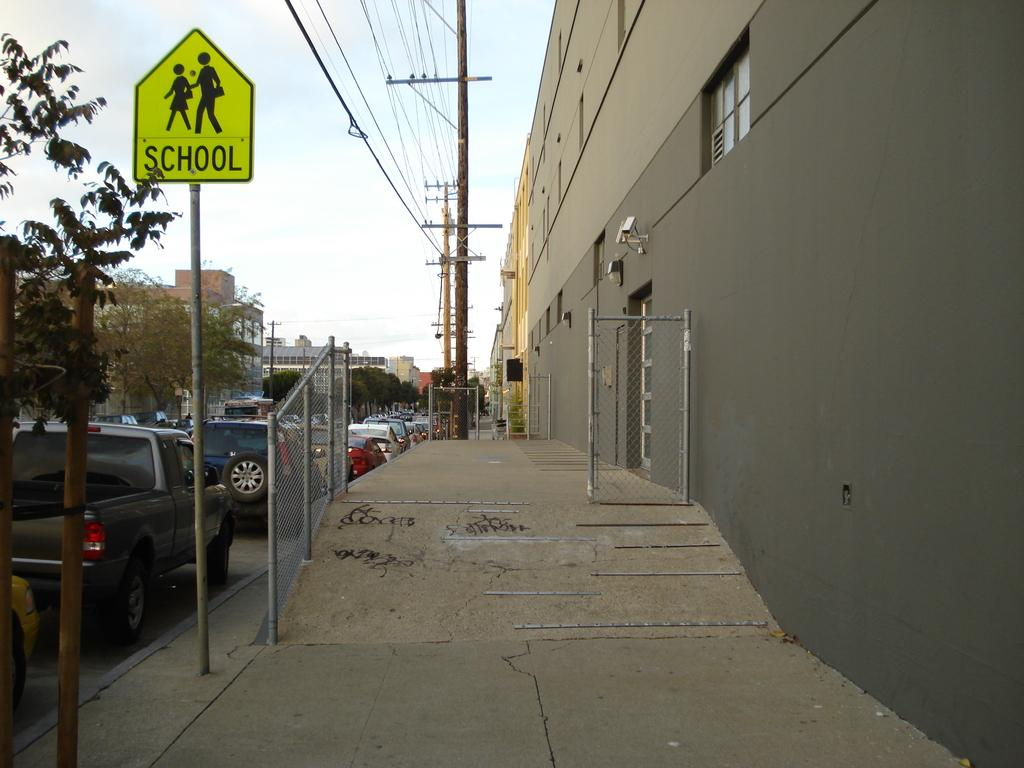<image>
Render a clear and concise summary of the photo. A bright yellow sign with text of School is mounted on a pole. 